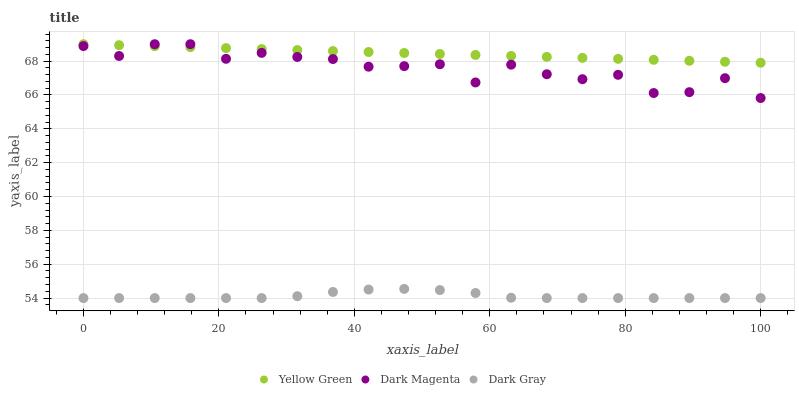Does Dark Gray have the minimum area under the curve?
Answer yes or no. Yes. Does Yellow Green have the maximum area under the curve?
Answer yes or no. Yes. Does Dark Magenta have the minimum area under the curve?
Answer yes or no. No. Does Dark Magenta have the maximum area under the curve?
Answer yes or no. No. Is Yellow Green the smoothest?
Answer yes or no. Yes. Is Dark Magenta the roughest?
Answer yes or no. Yes. Is Dark Magenta the smoothest?
Answer yes or no. No. Is Yellow Green the roughest?
Answer yes or no. No. Does Dark Gray have the lowest value?
Answer yes or no. Yes. Does Dark Magenta have the lowest value?
Answer yes or no. No. Does Dark Magenta have the highest value?
Answer yes or no. Yes. Is Dark Gray less than Yellow Green?
Answer yes or no. Yes. Is Yellow Green greater than Dark Gray?
Answer yes or no. Yes. Does Dark Magenta intersect Yellow Green?
Answer yes or no. Yes. Is Dark Magenta less than Yellow Green?
Answer yes or no. No. Is Dark Magenta greater than Yellow Green?
Answer yes or no. No. Does Dark Gray intersect Yellow Green?
Answer yes or no. No. 